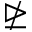<formula> <loc_0><loc_0><loc_500><loc_500>\ntrianglerighteq</formula> 